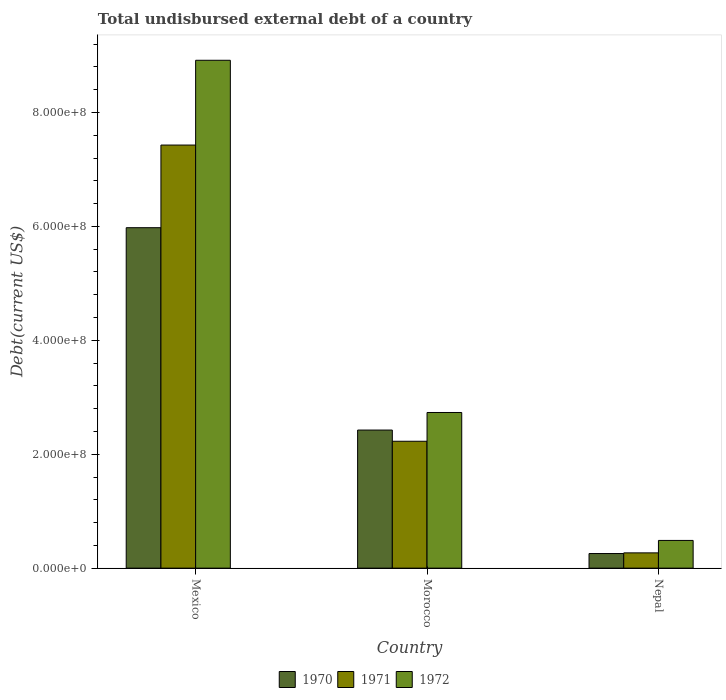Are the number of bars per tick equal to the number of legend labels?
Your answer should be very brief. Yes. How many bars are there on the 3rd tick from the right?
Offer a terse response. 3. What is the label of the 3rd group of bars from the left?
Give a very brief answer. Nepal. What is the total undisbursed external debt in 1971 in Mexico?
Your answer should be compact. 7.43e+08. Across all countries, what is the maximum total undisbursed external debt in 1970?
Give a very brief answer. 5.98e+08. Across all countries, what is the minimum total undisbursed external debt in 1972?
Your response must be concise. 4.87e+07. In which country was the total undisbursed external debt in 1970 minimum?
Your answer should be compact. Nepal. What is the total total undisbursed external debt in 1971 in the graph?
Your response must be concise. 9.92e+08. What is the difference between the total undisbursed external debt in 1971 in Morocco and that in Nepal?
Your response must be concise. 1.96e+08. What is the difference between the total undisbursed external debt in 1972 in Morocco and the total undisbursed external debt in 1971 in Mexico?
Keep it short and to the point. -4.70e+08. What is the average total undisbursed external debt in 1971 per country?
Your answer should be compact. 3.31e+08. What is the difference between the total undisbursed external debt of/in 1970 and total undisbursed external debt of/in 1972 in Mexico?
Provide a short and direct response. -2.94e+08. What is the ratio of the total undisbursed external debt in 1970 in Mexico to that in Nepal?
Give a very brief answer. 23.3. What is the difference between the highest and the second highest total undisbursed external debt in 1972?
Offer a terse response. 6.18e+08. What is the difference between the highest and the lowest total undisbursed external debt in 1971?
Offer a very short reply. 7.16e+08. What does the 1st bar from the left in Nepal represents?
Provide a short and direct response. 1970. Are all the bars in the graph horizontal?
Make the answer very short. No. How many countries are there in the graph?
Offer a terse response. 3. Does the graph contain any zero values?
Provide a short and direct response. No. Does the graph contain grids?
Your answer should be compact. No. How many legend labels are there?
Give a very brief answer. 3. How are the legend labels stacked?
Provide a succinct answer. Horizontal. What is the title of the graph?
Make the answer very short. Total undisbursed external debt of a country. Does "2010" appear as one of the legend labels in the graph?
Make the answer very short. No. What is the label or title of the X-axis?
Your answer should be very brief. Country. What is the label or title of the Y-axis?
Your answer should be compact. Debt(current US$). What is the Debt(current US$) in 1970 in Mexico?
Give a very brief answer. 5.98e+08. What is the Debt(current US$) in 1971 in Mexico?
Your response must be concise. 7.43e+08. What is the Debt(current US$) in 1972 in Mexico?
Your response must be concise. 8.92e+08. What is the Debt(current US$) in 1970 in Morocco?
Make the answer very short. 2.42e+08. What is the Debt(current US$) in 1971 in Morocco?
Give a very brief answer. 2.23e+08. What is the Debt(current US$) of 1972 in Morocco?
Your answer should be compact. 2.73e+08. What is the Debt(current US$) of 1970 in Nepal?
Offer a terse response. 2.57e+07. What is the Debt(current US$) of 1971 in Nepal?
Your response must be concise. 2.68e+07. What is the Debt(current US$) of 1972 in Nepal?
Keep it short and to the point. 4.87e+07. Across all countries, what is the maximum Debt(current US$) in 1970?
Your answer should be very brief. 5.98e+08. Across all countries, what is the maximum Debt(current US$) of 1971?
Your response must be concise. 7.43e+08. Across all countries, what is the maximum Debt(current US$) of 1972?
Provide a short and direct response. 8.92e+08. Across all countries, what is the minimum Debt(current US$) in 1970?
Your response must be concise. 2.57e+07. Across all countries, what is the minimum Debt(current US$) in 1971?
Give a very brief answer. 2.68e+07. Across all countries, what is the minimum Debt(current US$) of 1972?
Ensure brevity in your answer.  4.87e+07. What is the total Debt(current US$) of 1970 in the graph?
Give a very brief answer. 8.66e+08. What is the total Debt(current US$) in 1971 in the graph?
Your response must be concise. 9.92e+08. What is the total Debt(current US$) in 1972 in the graph?
Your answer should be very brief. 1.21e+09. What is the difference between the Debt(current US$) in 1970 in Mexico and that in Morocco?
Your answer should be compact. 3.55e+08. What is the difference between the Debt(current US$) of 1971 in Mexico and that in Morocco?
Provide a succinct answer. 5.20e+08. What is the difference between the Debt(current US$) of 1972 in Mexico and that in Morocco?
Your answer should be very brief. 6.18e+08. What is the difference between the Debt(current US$) of 1970 in Mexico and that in Nepal?
Your response must be concise. 5.72e+08. What is the difference between the Debt(current US$) of 1971 in Mexico and that in Nepal?
Keep it short and to the point. 7.16e+08. What is the difference between the Debt(current US$) of 1972 in Mexico and that in Nepal?
Keep it short and to the point. 8.43e+08. What is the difference between the Debt(current US$) of 1970 in Morocco and that in Nepal?
Offer a terse response. 2.17e+08. What is the difference between the Debt(current US$) of 1971 in Morocco and that in Nepal?
Offer a terse response. 1.96e+08. What is the difference between the Debt(current US$) of 1972 in Morocco and that in Nepal?
Your answer should be compact. 2.25e+08. What is the difference between the Debt(current US$) in 1970 in Mexico and the Debt(current US$) in 1971 in Morocco?
Your answer should be very brief. 3.75e+08. What is the difference between the Debt(current US$) of 1970 in Mexico and the Debt(current US$) of 1972 in Morocco?
Your answer should be very brief. 3.24e+08. What is the difference between the Debt(current US$) in 1971 in Mexico and the Debt(current US$) in 1972 in Morocco?
Provide a short and direct response. 4.70e+08. What is the difference between the Debt(current US$) in 1970 in Mexico and the Debt(current US$) in 1971 in Nepal?
Offer a terse response. 5.71e+08. What is the difference between the Debt(current US$) in 1970 in Mexico and the Debt(current US$) in 1972 in Nepal?
Make the answer very short. 5.49e+08. What is the difference between the Debt(current US$) of 1971 in Mexico and the Debt(current US$) of 1972 in Nepal?
Your answer should be compact. 6.94e+08. What is the difference between the Debt(current US$) in 1970 in Morocco and the Debt(current US$) in 1971 in Nepal?
Provide a succinct answer. 2.16e+08. What is the difference between the Debt(current US$) in 1970 in Morocco and the Debt(current US$) in 1972 in Nepal?
Keep it short and to the point. 1.94e+08. What is the difference between the Debt(current US$) in 1971 in Morocco and the Debt(current US$) in 1972 in Nepal?
Provide a short and direct response. 1.74e+08. What is the average Debt(current US$) of 1970 per country?
Your response must be concise. 2.89e+08. What is the average Debt(current US$) of 1971 per country?
Ensure brevity in your answer.  3.31e+08. What is the average Debt(current US$) in 1972 per country?
Make the answer very short. 4.05e+08. What is the difference between the Debt(current US$) in 1970 and Debt(current US$) in 1971 in Mexico?
Ensure brevity in your answer.  -1.45e+08. What is the difference between the Debt(current US$) of 1970 and Debt(current US$) of 1972 in Mexico?
Provide a short and direct response. -2.94e+08. What is the difference between the Debt(current US$) of 1971 and Debt(current US$) of 1972 in Mexico?
Provide a short and direct response. -1.49e+08. What is the difference between the Debt(current US$) in 1970 and Debt(current US$) in 1971 in Morocco?
Keep it short and to the point. 1.97e+07. What is the difference between the Debt(current US$) of 1970 and Debt(current US$) of 1972 in Morocco?
Keep it short and to the point. -3.08e+07. What is the difference between the Debt(current US$) of 1971 and Debt(current US$) of 1972 in Morocco?
Your answer should be compact. -5.05e+07. What is the difference between the Debt(current US$) in 1970 and Debt(current US$) in 1971 in Nepal?
Ensure brevity in your answer.  -1.17e+06. What is the difference between the Debt(current US$) of 1970 and Debt(current US$) of 1972 in Nepal?
Your answer should be very brief. -2.30e+07. What is the difference between the Debt(current US$) in 1971 and Debt(current US$) in 1972 in Nepal?
Give a very brief answer. -2.18e+07. What is the ratio of the Debt(current US$) in 1970 in Mexico to that in Morocco?
Provide a short and direct response. 2.47. What is the ratio of the Debt(current US$) in 1971 in Mexico to that in Morocco?
Your answer should be very brief. 3.33. What is the ratio of the Debt(current US$) in 1972 in Mexico to that in Morocco?
Your answer should be very brief. 3.26. What is the ratio of the Debt(current US$) of 1970 in Mexico to that in Nepal?
Provide a succinct answer. 23.3. What is the ratio of the Debt(current US$) of 1971 in Mexico to that in Nepal?
Provide a succinct answer. 27.69. What is the ratio of the Debt(current US$) in 1972 in Mexico to that in Nepal?
Offer a very short reply. 18.32. What is the ratio of the Debt(current US$) of 1970 in Morocco to that in Nepal?
Your response must be concise. 9.45. What is the ratio of the Debt(current US$) in 1971 in Morocco to that in Nepal?
Make the answer very short. 8.3. What is the ratio of the Debt(current US$) in 1972 in Morocco to that in Nepal?
Offer a terse response. 5.62. What is the difference between the highest and the second highest Debt(current US$) of 1970?
Provide a short and direct response. 3.55e+08. What is the difference between the highest and the second highest Debt(current US$) of 1971?
Provide a short and direct response. 5.20e+08. What is the difference between the highest and the second highest Debt(current US$) in 1972?
Your answer should be very brief. 6.18e+08. What is the difference between the highest and the lowest Debt(current US$) of 1970?
Give a very brief answer. 5.72e+08. What is the difference between the highest and the lowest Debt(current US$) in 1971?
Your response must be concise. 7.16e+08. What is the difference between the highest and the lowest Debt(current US$) in 1972?
Ensure brevity in your answer.  8.43e+08. 